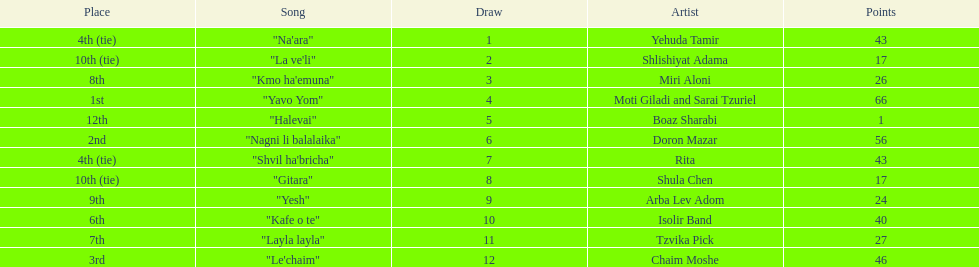Parse the table in full. {'header': ['Place', 'Song', 'Draw', 'Artist', 'Points'], 'rows': [['4th (tie)', '"Na\'ara"', '1', 'Yehuda Tamir', '43'], ['10th (tie)', '"La ve\'li"', '2', 'Shlishiyat Adama', '17'], ['8th', '"Kmo ha\'emuna"', '3', 'Miri Aloni', '26'], ['1st', '"Yavo Yom"', '4', 'Moti Giladi and Sarai Tzuriel', '66'], ['12th', '"Halevai"', '5', 'Boaz Sharabi', '1'], ['2nd', '"Nagni li balalaika"', '6', 'Doron Mazar', '56'], ['4th (tie)', '"Shvil ha\'bricha"', '7', 'Rita', '43'], ['10th (tie)', '"Gitara"', '8', 'Shula Chen', '17'], ['9th', '"Yesh"', '9', 'Arba Lev Adom', '24'], ['6th', '"Kafe o te"', '10', 'Isolir Band', '40'], ['7th', '"Layla layla"', '11', 'Tzvika Pick', '27'], ['3rd', '"Le\'chaim"', '12', 'Chaim Moshe', '46']]} Did the song "gitara" or "yesh" earn more points? "Yesh". 